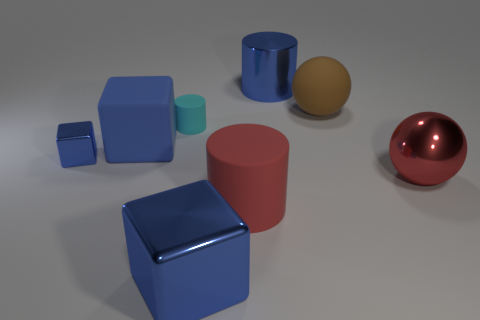How many big yellow matte things are there?
Your answer should be very brief. 0. How many blocks are red things or small objects?
Make the answer very short. 1. There is a matte cylinder behind the large blue cube behind the tiny blue thing; how many blue things are behind it?
Offer a very short reply. 1. There is a metal object that is the same size as the cyan cylinder; what is its color?
Your answer should be compact. Blue. How many other things are there of the same color as the big shiny ball?
Provide a short and direct response. 1. Are there more shiny things that are to the left of the large metallic block than small yellow matte cubes?
Your response must be concise. Yes. Is the material of the red cylinder the same as the small blue object?
Make the answer very short. No. How many objects are either blue metal objects that are behind the small blue cube or big brown objects?
Provide a short and direct response. 2. How many other objects are there of the same size as the brown matte thing?
Your answer should be very brief. 5. Is the number of large red things that are behind the big blue cylinder the same as the number of small metallic blocks that are on the right side of the cyan matte object?
Your response must be concise. Yes. 